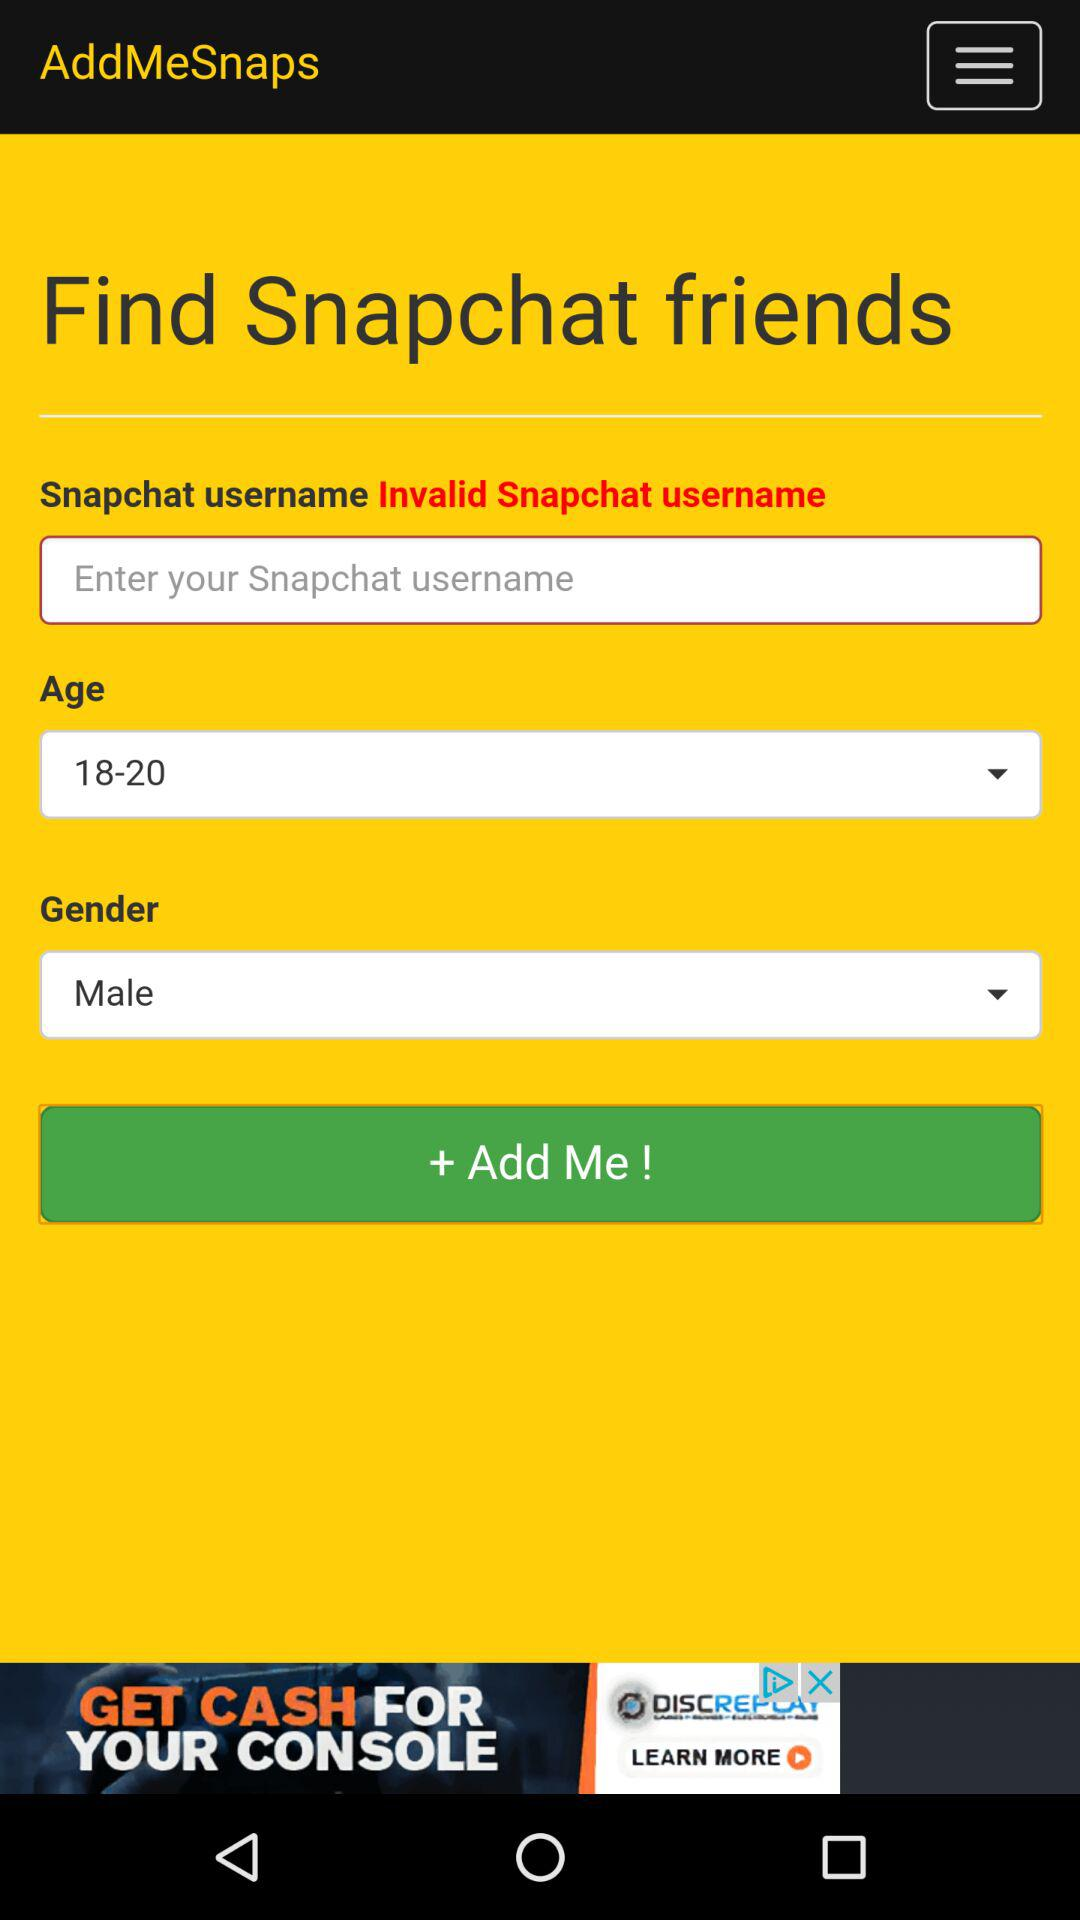What is the selected age group? The selected age group is 18–20. 